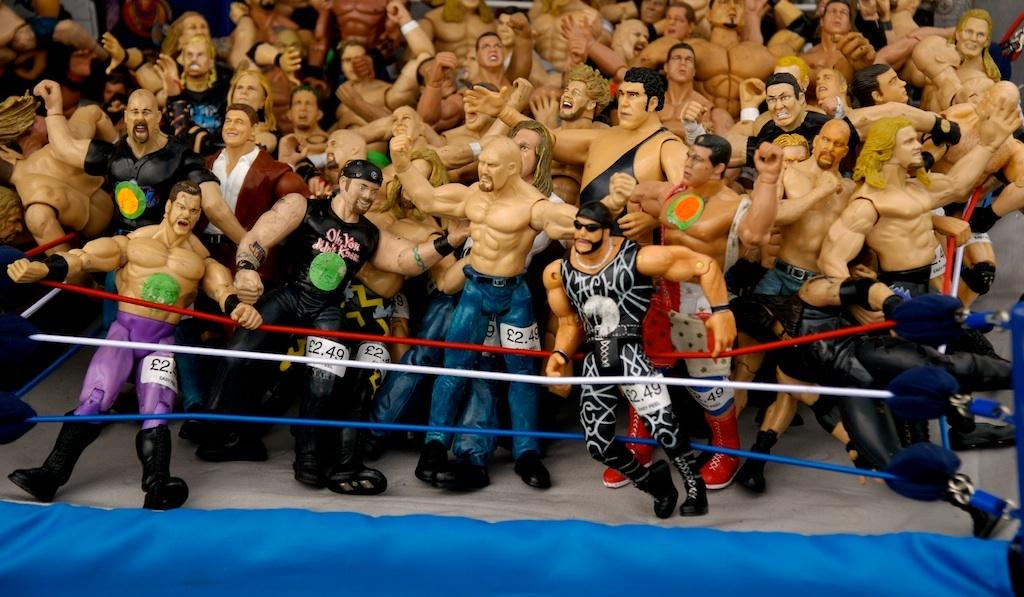What type of objects can be seen in the image? There are toys and ropes in the image. Can you describe the blue color object in the image? There is a blue color object at the bottom of the image. What type of car is parked next to the beggar in the image? There is no car or beggar present in the image; it only features toys and ropes. 